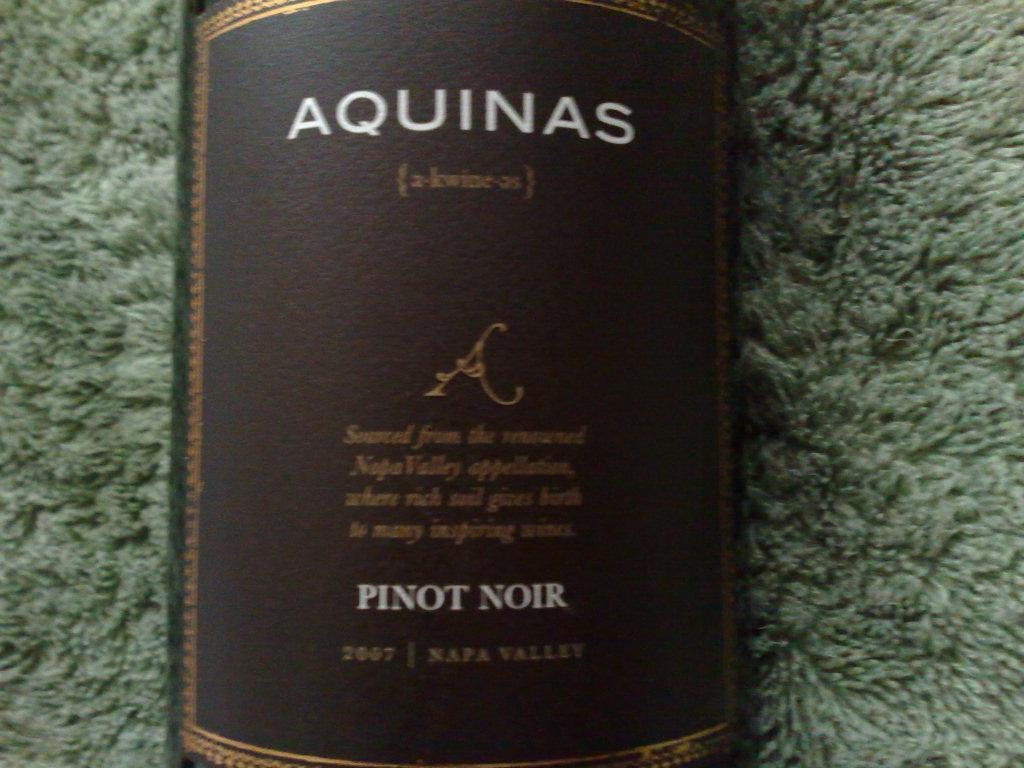<image>
Share a concise interpretation of the image provided. A bottle of pinot noir says "AQUINAS" on the label. 